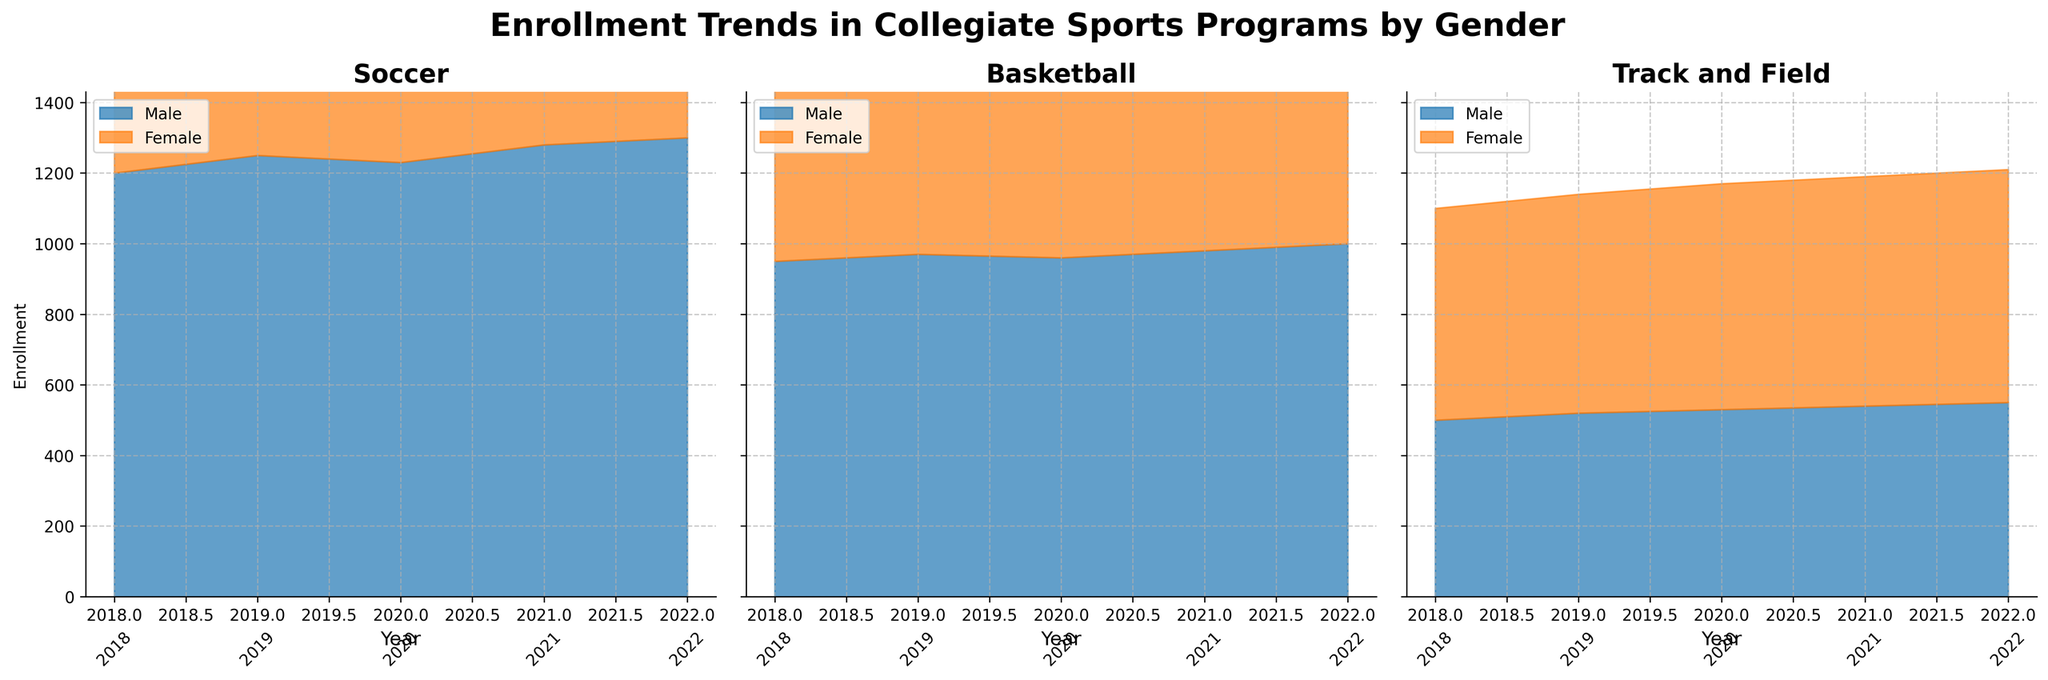1. What is the title of the figure? The title of the figure is displayed at the top and summarizes the main topic of the data visualized.
Answer: Enrollment Trends in Collegiate Sports Programs by Gender 2. How many sports programs are shown in the figure? The figure contains separate subplots for each sports program, identifiable by their individual titles.
Answer: 3 3. Which sport had the highest male enrollment in 2022? By looking at the endpoint of the blue-colored area for 2022 in each subplot, we can compare the heights.
Answer: Soccer 4. Did female enrollment in basketball increase or decrease from 2018 to 2019? Check the height of the orange-colored area for female enrollments in basketball from 2018 to 2019.
Answer: Increase 5. What is the trend in male enrollment for Soccer from 2018 to 2022? Observe how the blue-colored area for male enrollments in the Soccer subplot changes over the years from 2018 to 2022.
Answer: Increasing 6. In 2020, which sport had a larger female enrollment, Soccer or Track and Field? Compare the heights of the orange-colored areas for females in Soccer and Track and Field in 2020.
Answer: Soccer 7. How did the total enrollment for Basketball change from 2018 to 2022? Stack the areas for both male and female enrollments in Basketball from 2018 to 2022 to see the trend.
Answer: Increased 8. What was the enrollment difference between male and female athletes in Track and Field in 2021? Subtract the height of the orange area (female) from the blue area (male) for Track and Field in 2021.
Answer: -110 9. Across all years, which gender had higher enrollment in Soccer? Compare the combined areas of blue and orange colors for male and female enrollments in Soccer across all years.
Answer: Male 10. What is the overall trend in female enrollment in all three sports programs from 2018 to 2022? Examine the heights of the orange-colored areas for female enrollments in all three subplots over the years 2018 to 2022.
Answer: Increasing 